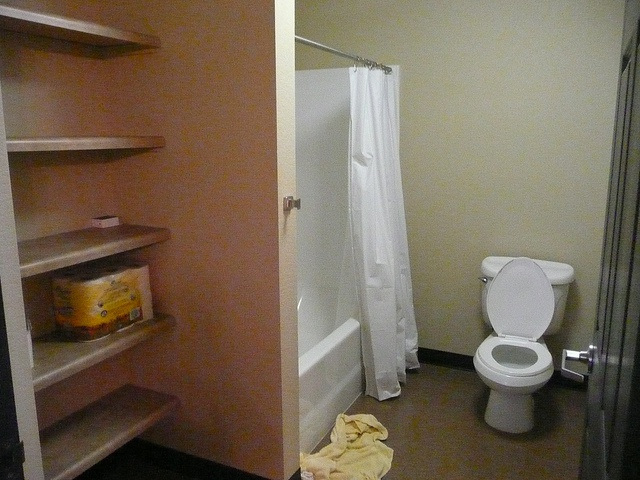Describe the objects in this image and their specific colors. I can see a toilet in gray, darkgray, black, and lightgray tones in this image. 